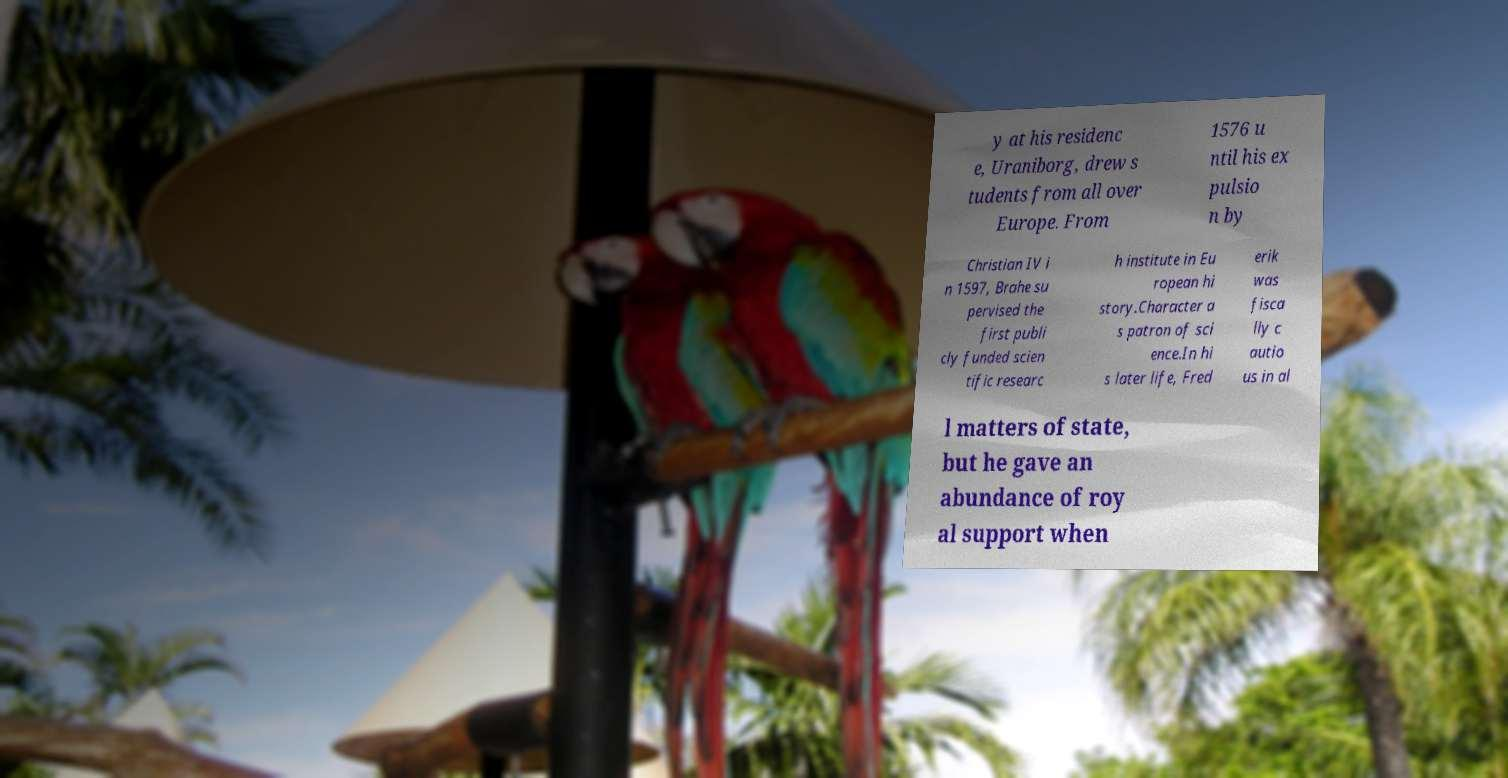Could you extract and type out the text from this image? y at his residenc e, Uraniborg, drew s tudents from all over Europe. From 1576 u ntil his ex pulsio n by Christian IV i n 1597, Brahe su pervised the first publi cly funded scien tific researc h institute in Eu ropean hi story.Character a s patron of sci ence.In hi s later life, Fred erik was fisca lly c autio us in al l matters of state, but he gave an abundance of roy al support when 